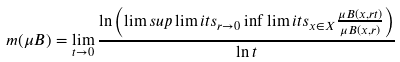<formula> <loc_0><loc_0><loc_500><loc_500>m ( \mu B ) = \lim _ { t \to 0 } \frac { \ln \left ( \lim s u p \lim i t s _ { r \to 0 } \inf \lim i t s _ { x \in X } \frac { \mu B ( x , r t ) } { \mu B ( x , r ) } \right ) } { \ln t }</formula> 